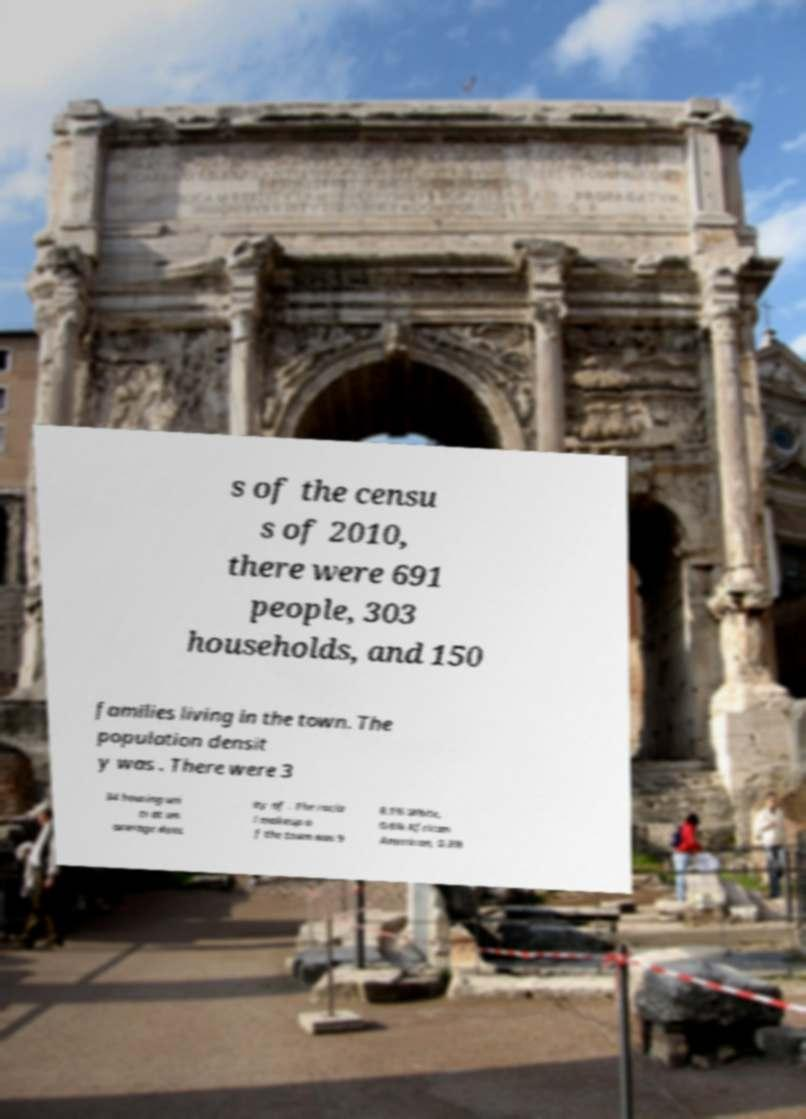Could you assist in decoding the text presented in this image and type it out clearly? s of the censu s of 2010, there were 691 people, 303 households, and 150 families living in the town. The population densit y was . There were 3 34 housing uni ts at an average dens ity of . The racia l makeup o f the town was 9 8.1% White, 0.6% African American, 0.3% 